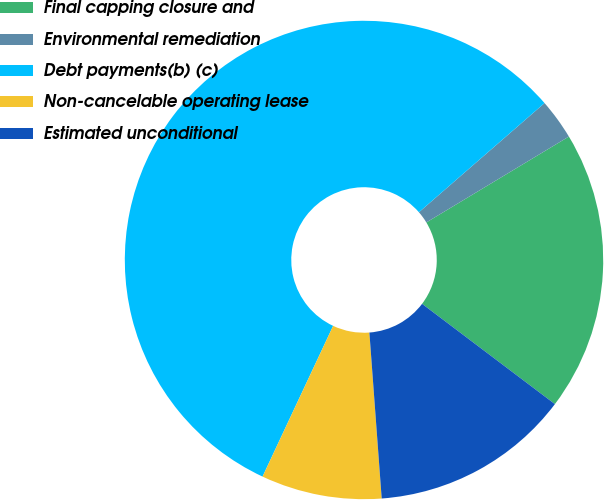<chart> <loc_0><loc_0><loc_500><loc_500><pie_chart><fcel>Final capping closure and<fcel>Environmental remediation<fcel>Debt payments(b) (c)<fcel>Non-cancelable operating lease<fcel>Estimated unconditional<nl><fcel>18.92%<fcel>2.76%<fcel>56.64%<fcel>8.15%<fcel>13.53%<nl></chart> 